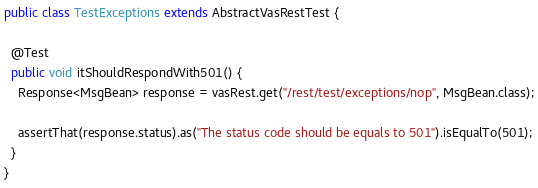Convert code to text. <code><loc_0><loc_0><loc_500><loc_500><_Java_>
public class TestExceptions extends AbstractVasRestTest {

  @Test
  public void itShouldRespondWith501() {
    Response<MsgBean> response = vasRest.get("/rest/test/exceptions/nop", MsgBean.class);

    assertThat(response.status).as("The status code should be equals to 501").isEqualTo(501);
  }
}
</code> 